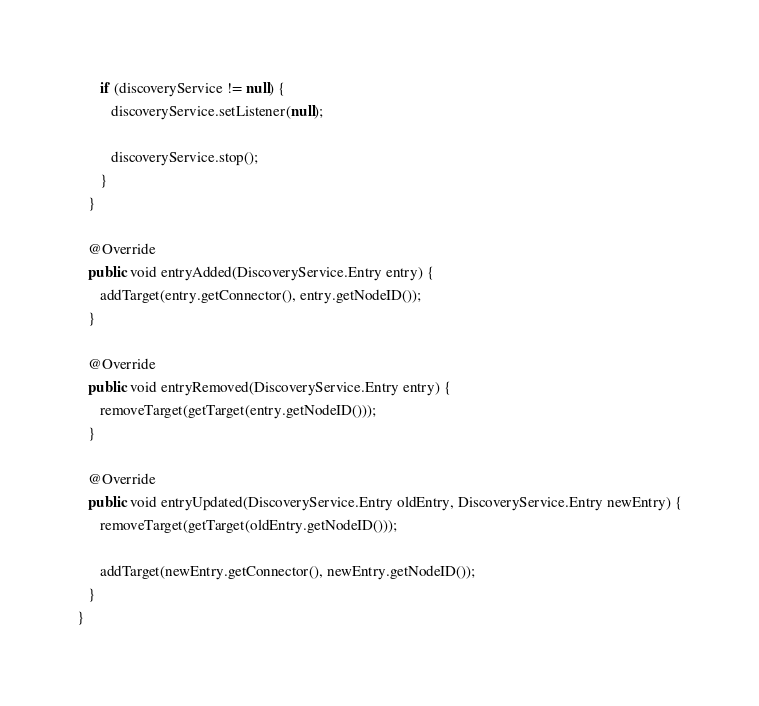Convert code to text. <code><loc_0><loc_0><loc_500><loc_500><_Java_>      if (discoveryService != null) {
         discoveryService.setListener(null);

         discoveryService.stop();
      }
   }

   @Override
   public void entryAdded(DiscoveryService.Entry entry) {
      addTarget(entry.getConnector(), entry.getNodeID());
   }

   @Override
   public void entryRemoved(DiscoveryService.Entry entry) {
      removeTarget(getTarget(entry.getNodeID()));
   }

   @Override
   public void entryUpdated(DiscoveryService.Entry oldEntry, DiscoveryService.Entry newEntry) {
      removeTarget(getTarget(oldEntry.getNodeID()));

      addTarget(newEntry.getConnector(), newEntry.getNodeID());
   }
}
</code> 